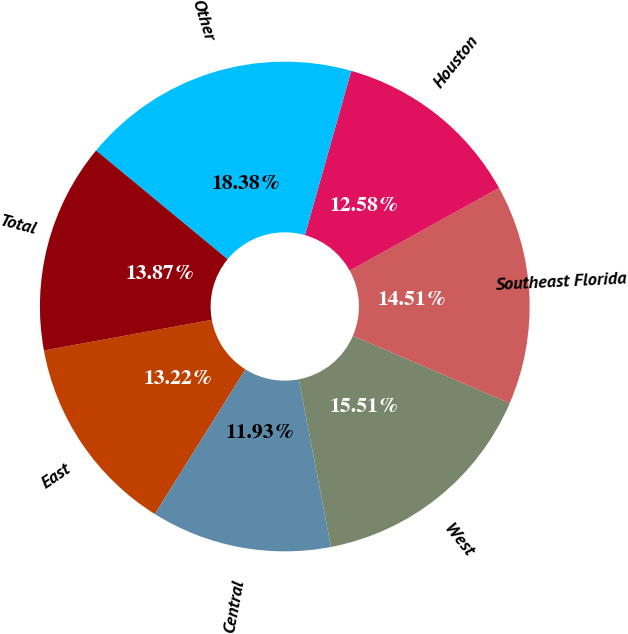Convert chart to OTSL. <chart><loc_0><loc_0><loc_500><loc_500><pie_chart><fcel>East<fcel>Central<fcel>West<fcel>Southeast Florida<fcel>Houston<fcel>Other<fcel>Total<nl><fcel>13.22%<fcel>11.93%<fcel>15.51%<fcel>14.51%<fcel>12.58%<fcel>18.38%<fcel>13.87%<nl></chart> 